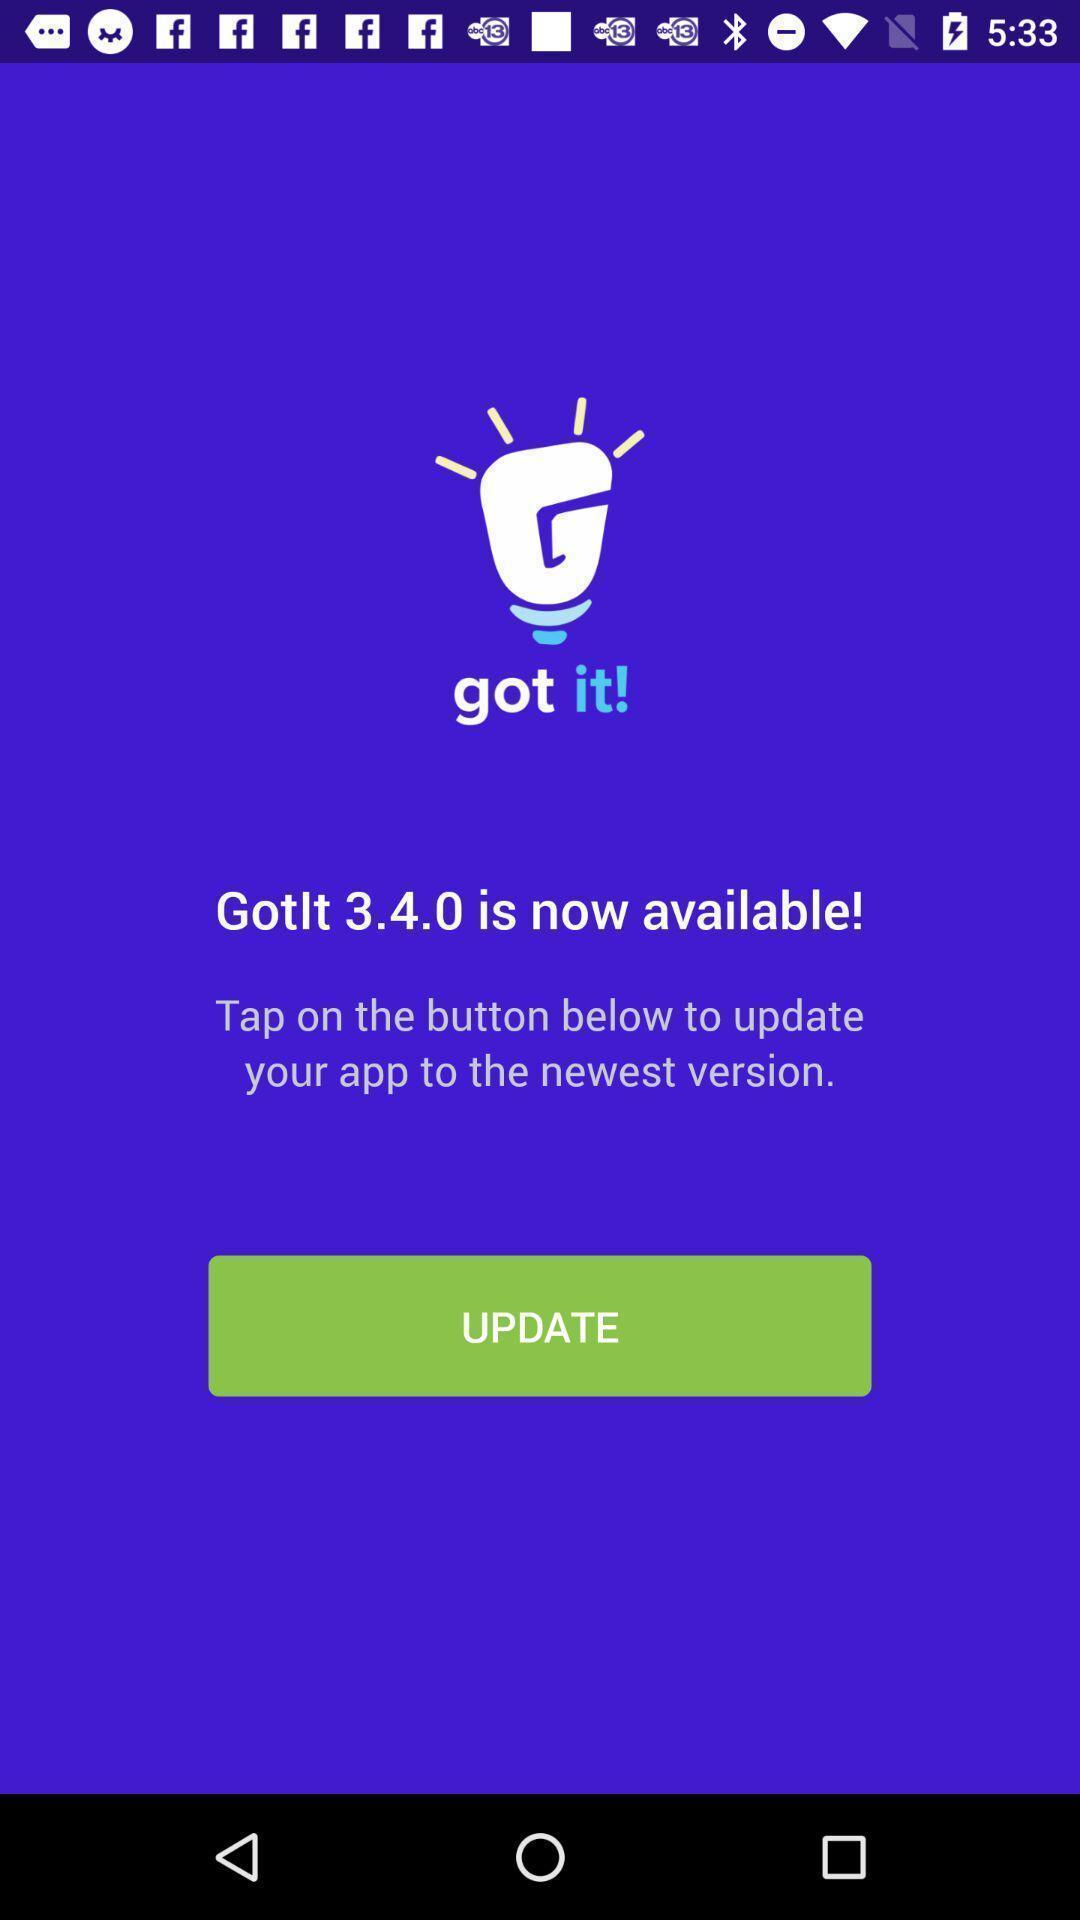Summarize the main components in this picture. Welcome page displaying update information of application. 